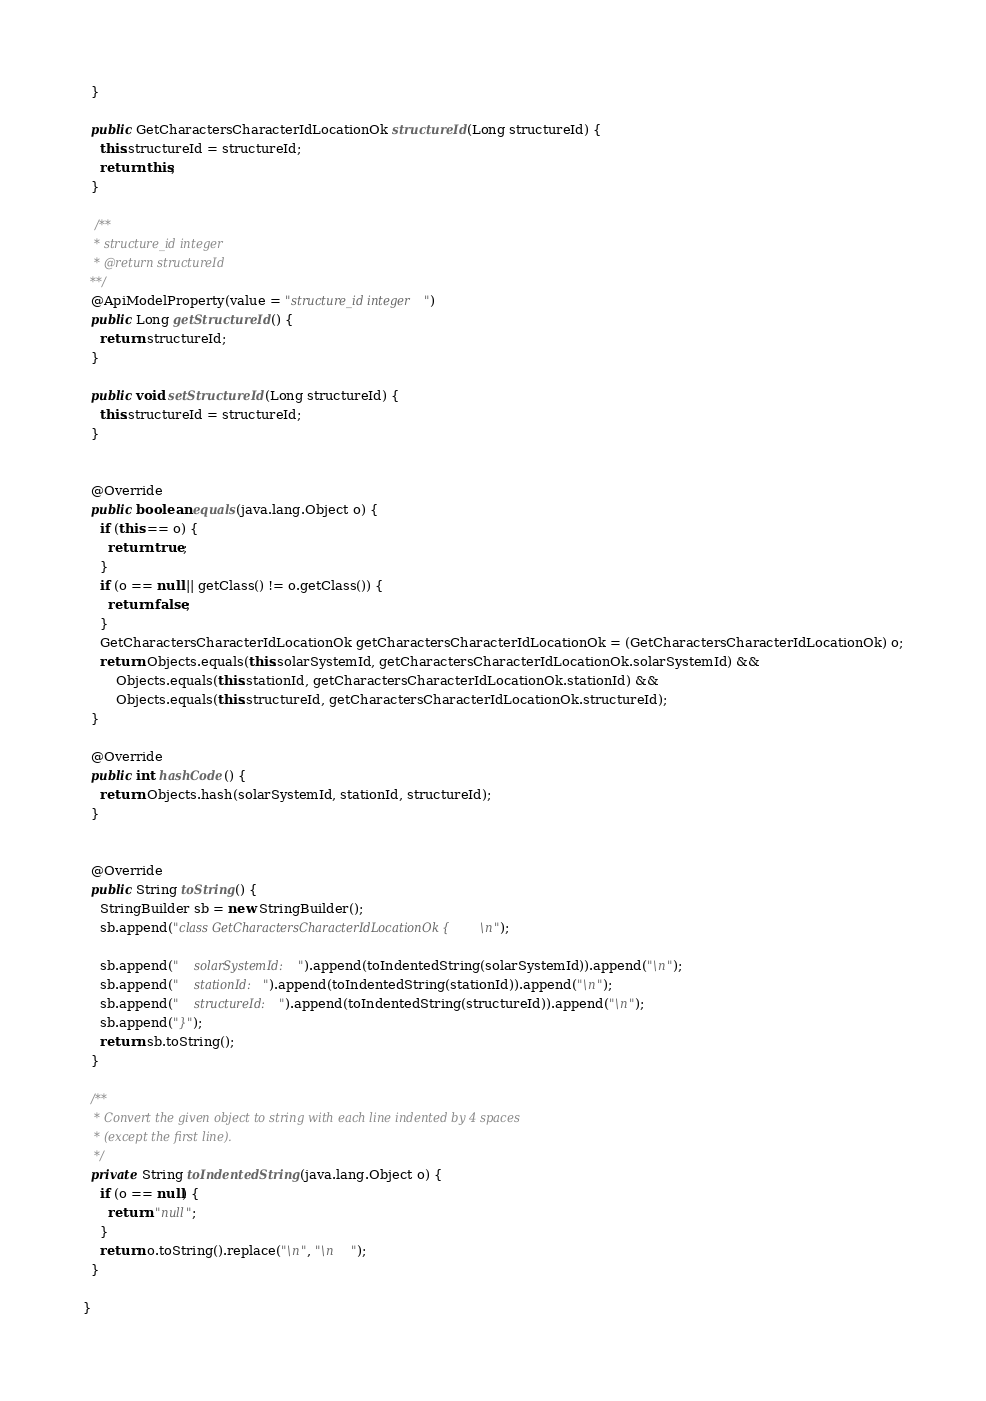Convert code to text. <code><loc_0><loc_0><loc_500><loc_500><_Java_>  }

  public GetCharactersCharacterIdLocationOk structureId(Long structureId) {
    this.structureId = structureId;
    return this;
  }

   /**
   * structure_id integer
   * @return structureId
  **/
  @ApiModelProperty(value = "structure_id integer")
  public Long getStructureId() {
    return structureId;
  }

  public void setStructureId(Long structureId) {
    this.structureId = structureId;
  }


  @Override
  public boolean equals(java.lang.Object o) {
    if (this == o) {
      return true;
    }
    if (o == null || getClass() != o.getClass()) {
      return false;
    }
    GetCharactersCharacterIdLocationOk getCharactersCharacterIdLocationOk = (GetCharactersCharacterIdLocationOk) o;
    return Objects.equals(this.solarSystemId, getCharactersCharacterIdLocationOk.solarSystemId) &&
        Objects.equals(this.stationId, getCharactersCharacterIdLocationOk.stationId) &&
        Objects.equals(this.structureId, getCharactersCharacterIdLocationOk.structureId);
  }

  @Override
  public int hashCode() {
    return Objects.hash(solarSystemId, stationId, structureId);
  }


  @Override
  public String toString() {
    StringBuilder sb = new StringBuilder();
    sb.append("class GetCharactersCharacterIdLocationOk {\n");
    
    sb.append("    solarSystemId: ").append(toIndentedString(solarSystemId)).append("\n");
    sb.append("    stationId: ").append(toIndentedString(stationId)).append("\n");
    sb.append("    structureId: ").append(toIndentedString(structureId)).append("\n");
    sb.append("}");
    return sb.toString();
  }

  /**
   * Convert the given object to string with each line indented by 4 spaces
   * (except the first line).
   */
  private String toIndentedString(java.lang.Object o) {
    if (o == null) {
      return "null";
    }
    return o.toString().replace("\n", "\n    ");
  }

}

</code> 